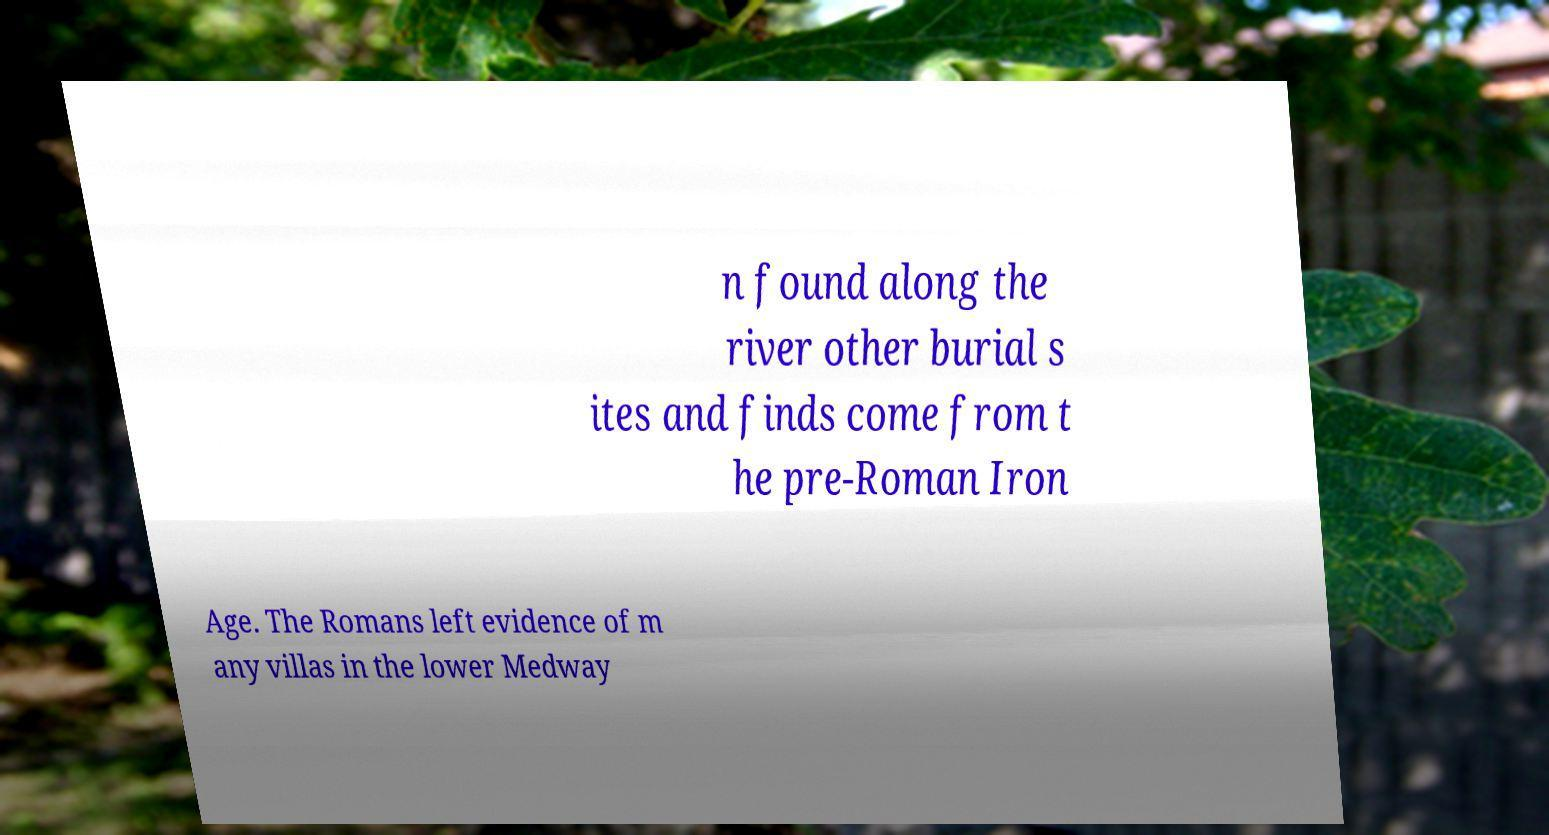For documentation purposes, I need the text within this image transcribed. Could you provide that? n found along the river other burial s ites and finds come from t he pre-Roman Iron Age. The Romans left evidence of m any villas in the lower Medway 